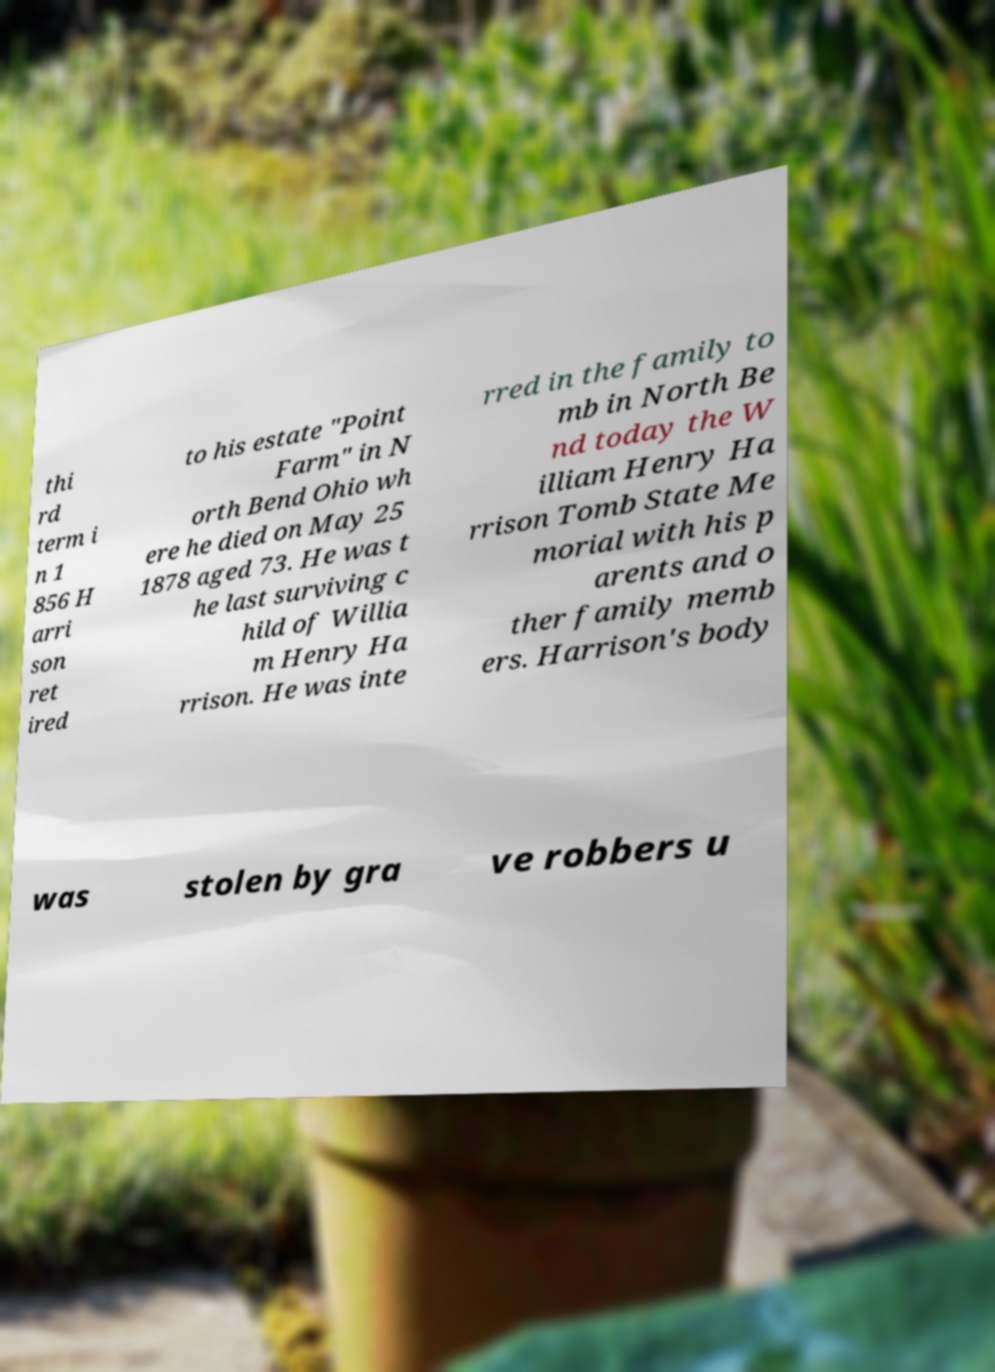Please identify and transcribe the text found in this image. thi rd term i n 1 856 H arri son ret ired to his estate "Point Farm" in N orth Bend Ohio wh ere he died on May 25 1878 aged 73. He was t he last surviving c hild of Willia m Henry Ha rrison. He was inte rred in the family to mb in North Be nd today the W illiam Henry Ha rrison Tomb State Me morial with his p arents and o ther family memb ers. Harrison's body was stolen by gra ve robbers u 